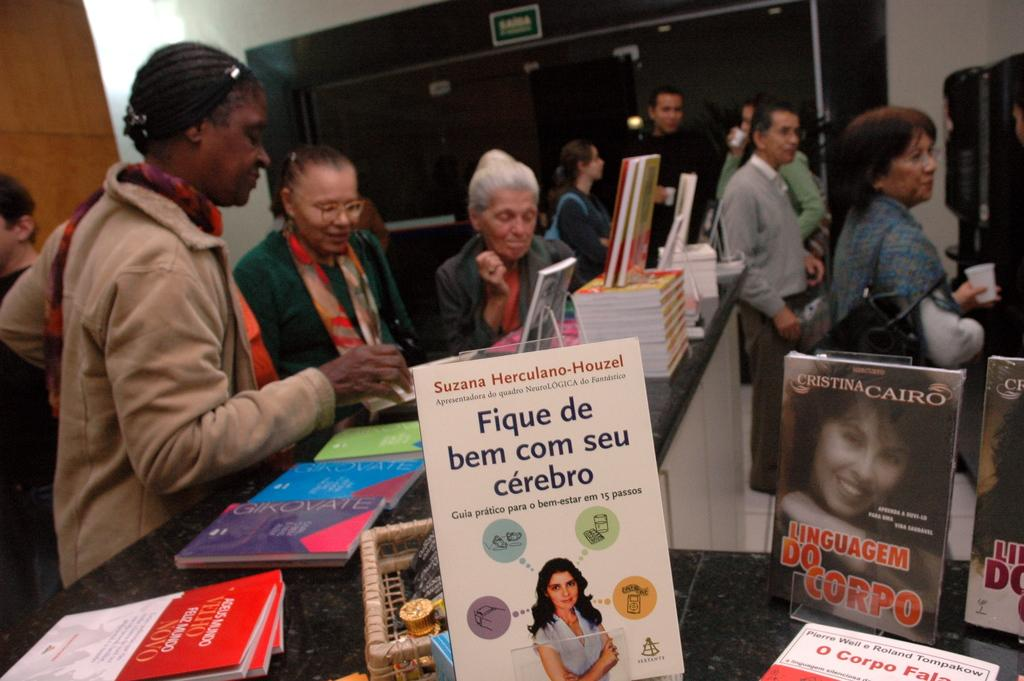<image>
Give a short and clear explanation of the subsequent image. An assortment of books are displayed on a counter including one by author Cristina Cairo. 